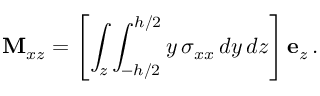<formula> <loc_0><loc_0><loc_500><loc_500>M _ { x z } = \left [ \int _ { z } \int _ { - h / 2 } ^ { h / 2 } y \, \sigma _ { x x } \, d y \, d z \right ] e _ { z } \, .</formula> 